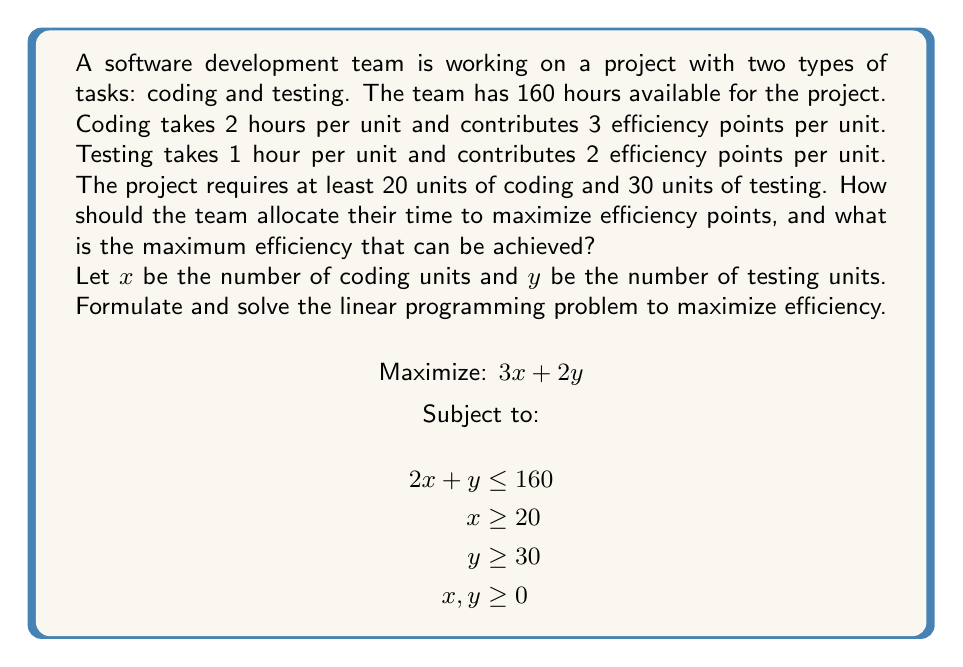Give your solution to this math problem. To solve this linear programming problem, we'll follow these steps:

1) First, let's identify the corner points of the feasible region. These are the points where the constraints intersect.

2) The constraints are:
   - $2x + y = 160$ (time constraint)
   - $x = 20$ (minimum coding units)
   - $y = 30$ (minimum testing units)

3) Let's find the intersection points:
   a) $(20, 30)$ satisfies the minimum requirements
   b) $(20, 120)$ intersection of $x = 20$ and $2x + y = 160$
   c) $(65, 30)$ intersection of $y = 30$ and $2x + y = 160$

4) Now, we evaluate the objective function $3x + 2y$ at each of these points:
   a) At $(20, 30)$: $3(20) + 2(30) = 120$
   b) At $(20, 120)$: $3(20) + 2(120) = 300$
   c) At $(65, 30)$: $3(65) + 2(30) = 255$

5) The maximum value is 300, occurring at the point $(20, 120)$.

Therefore, the team should allocate time for 20 units of coding and 120 units of testing to maximize efficiency.

To verify this solution satisfies all constraints:
- Time constraint: $2(20) + 120 = 160$ hours (satisfied)
- Minimum coding: 20 units (satisfied)
- Minimum testing: 120 units > 30 (satisfied)
Answer: The team should allocate time for 20 units of coding and 120 units of testing. The maximum efficiency that can be achieved is 300 efficiency points. 